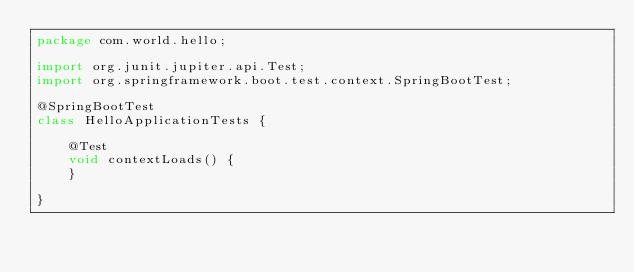Convert code to text. <code><loc_0><loc_0><loc_500><loc_500><_Java_>package com.world.hello;

import org.junit.jupiter.api.Test;
import org.springframework.boot.test.context.SpringBootTest;

@SpringBootTest
class HelloApplicationTests {

	@Test
	void contextLoads() {
	}

}
</code> 